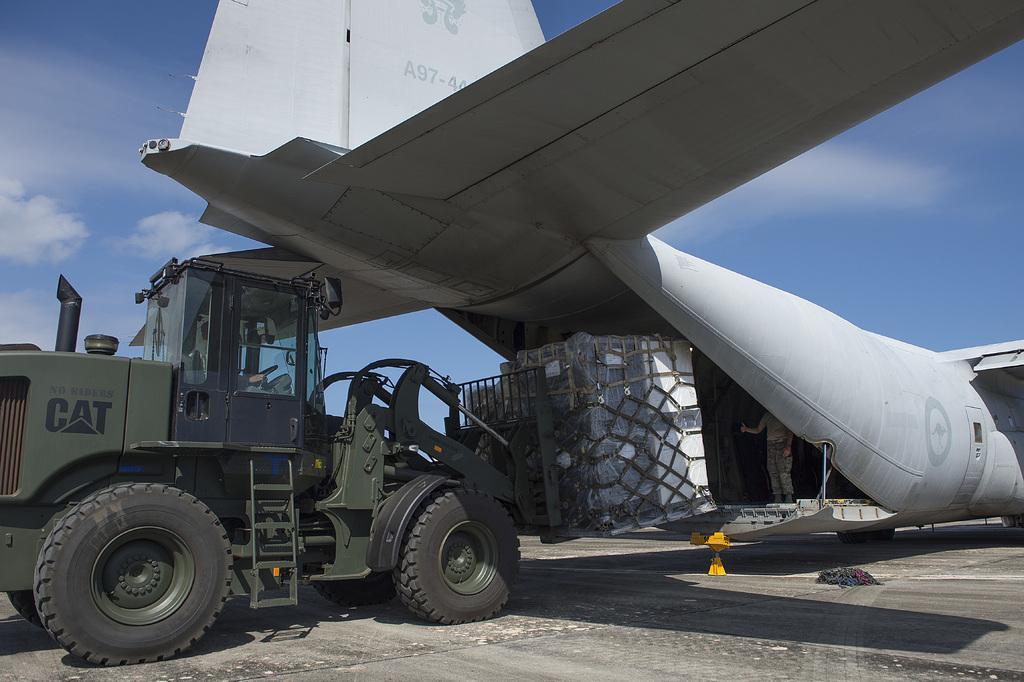In one or two sentences, can you explain what this image depicts? In this picture I can observe an airplane in the middle of the picture. On the left side I can observe a crane. In the background I can observe sky. 